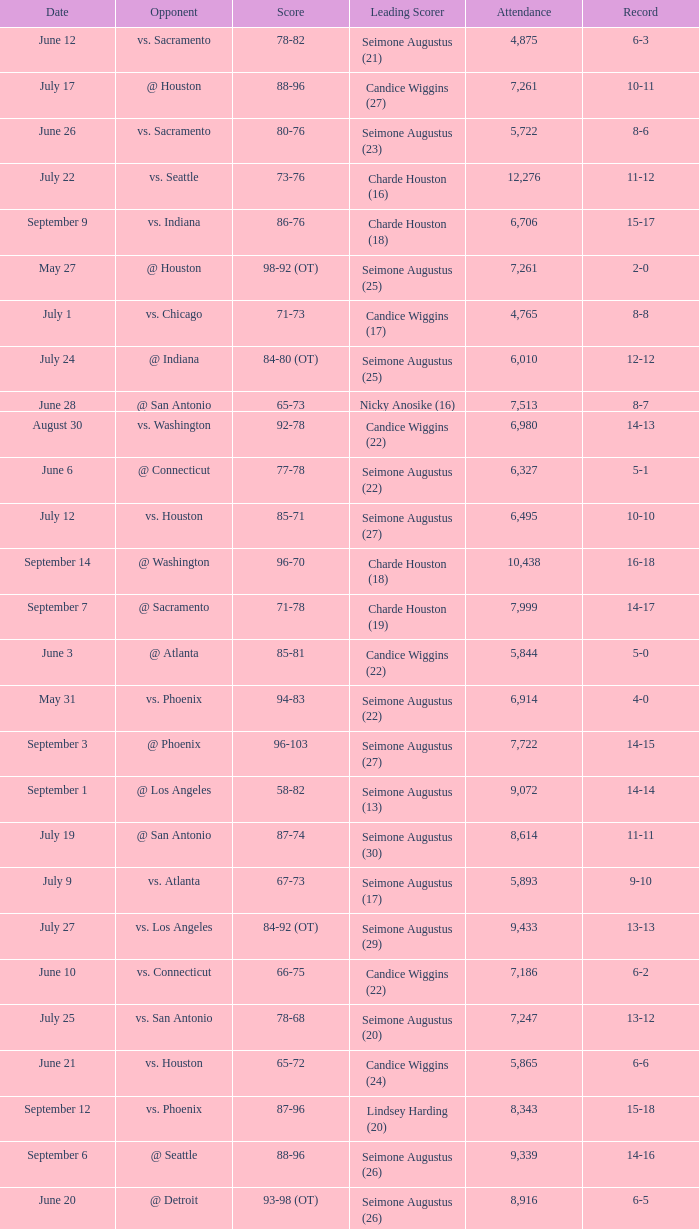Give me the full table as a dictionary. {'header': ['Date', 'Opponent', 'Score', 'Leading Scorer', 'Attendance', 'Record'], 'rows': [['June 12', 'vs. Sacramento', '78-82', 'Seimone Augustus (21)', '4,875', '6-3'], ['July 17', '@ Houston', '88-96', 'Candice Wiggins (27)', '7,261', '10-11'], ['June 26', 'vs. Sacramento', '80-76', 'Seimone Augustus (23)', '5,722', '8-6'], ['July 22', 'vs. Seattle', '73-76', 'Charde Houston (16)', '12,276', '11-12'], ['September 9', 'vs. Indiana', '86-76', 'Charde Houston (18)', '6,706', '15-17'], ['May 27', '@ Houston', '98-92 (OT)', 'Seimone Augustus (25)', '7,261', '2-0'], ['July 1', 'vs. Chicago', '71-73', 'Candice Wiggins (17)', '4,765', '8-8'], ['July 24', '@ Indiana', '84-80 (OT)', 'Seimone Augustus (25)', '6,010', '12-12'], ['June 28', '@ San Antonio', '65-73', 'Nicky Anosike (16)', '7,513', '8-7'], ['August 30', 'vs. Washington', '92-78', 'Candice Wiggins (22)', '6,980', '14-13'], ['June 6', '@ Connecticut', '77-78', 'Seimone Augustus (22)', '6,327', '5-1'], ['July 12', 'vs. Houston', '85-71', 'Seimone Augustus (27)', '6,495', '10-10'], ['September 14', '@ Washington', '96-70', 'Charde Houston (18)', '10,438', '16-18'], ['September 7', '@ Sacramento', '71-78', 'Charde Houston (19)', '7,999', '14-17'], ['June 3', '@ Atlanta', '85-81', 'Candice Wiggins (22)', '5,844', '5-0'], ['May 31', 'vs. Phoenix', '94-83', 'Seimone Augustus (22)', '6,914', '4-0'], ['September 3', '@ Phoenix', '96-103', 'Seimone Augustus (27)', '7,722', '14-15'], ['September 1', '@ Los Angeles', '58-82', 'Seimone Augustus (13)', '9,072', '14-14'], ['July 19', '@ San Antonio', '87-74', 'Seimone Augustus (30)', '8,614', '11-11'], ['July 9', 'vs. Atlanta', '67-73', 'Seimone Augustus (17)', '5,893', '9-10'], ['July 27', 'vs. Los Angeles', '84-92 (OT)', 'Seimone Augustus (29)', '9,433', '13-13'], ['June 10', 'vs. Connecticut', '66-75', 'Candice Wiggins (22)', '7,186', '6-2'], ['July 25', 'vs. San Antonio', '78-68', 'Seimone Augustus (20)', '7,247', '13-12'], ['June 21', 'vs. Houston', '65-72', 'Candice Wiggins (24)', '5,865', '6-6'], ['September 12', 'vs. Phoenix', '87-96', 'Lindsey Harding (20)', '8,343', '15-18'], ['September 6', '@ Seattle', '88-96', 'Seimone Augustus (26)', '9,339', '14-16'], ['June 20', '@ Detroit', '93-98 (OT)', 'Seimone Augustus (26)', '8,916', '6-5'], ['June 24', 'vs. New York', '91-69', 'Seimone Augustus (21)', '6,280', '7-6'], ['July 3', '@ Los Angeles', '88-70', 'Seimone Augustus (29)', '8,587', '9-8'], ['May 18', 'vs. Detroit', '84-70', 'Charde Houston (21)', '9,972', '1-0'], ['June 14', '@ New York', '76-77', 'Candice Wiggins (26)', '7,452', '6-4'], ['May 29', '@ Chicago', '75-69', 'Seimone Augustus (19)', '3,014', '3-0'], ['July 5', '@ Seattle', '71-96', 'Nicky Anosike (15)', '7,553', '9-9'], ['June 8', 'vs. San Antonio', '90-78', 'Seimone Augustus (18)', '5,020', '6-1']]} Which Attendance has a Date of september 7? 7999.0. 